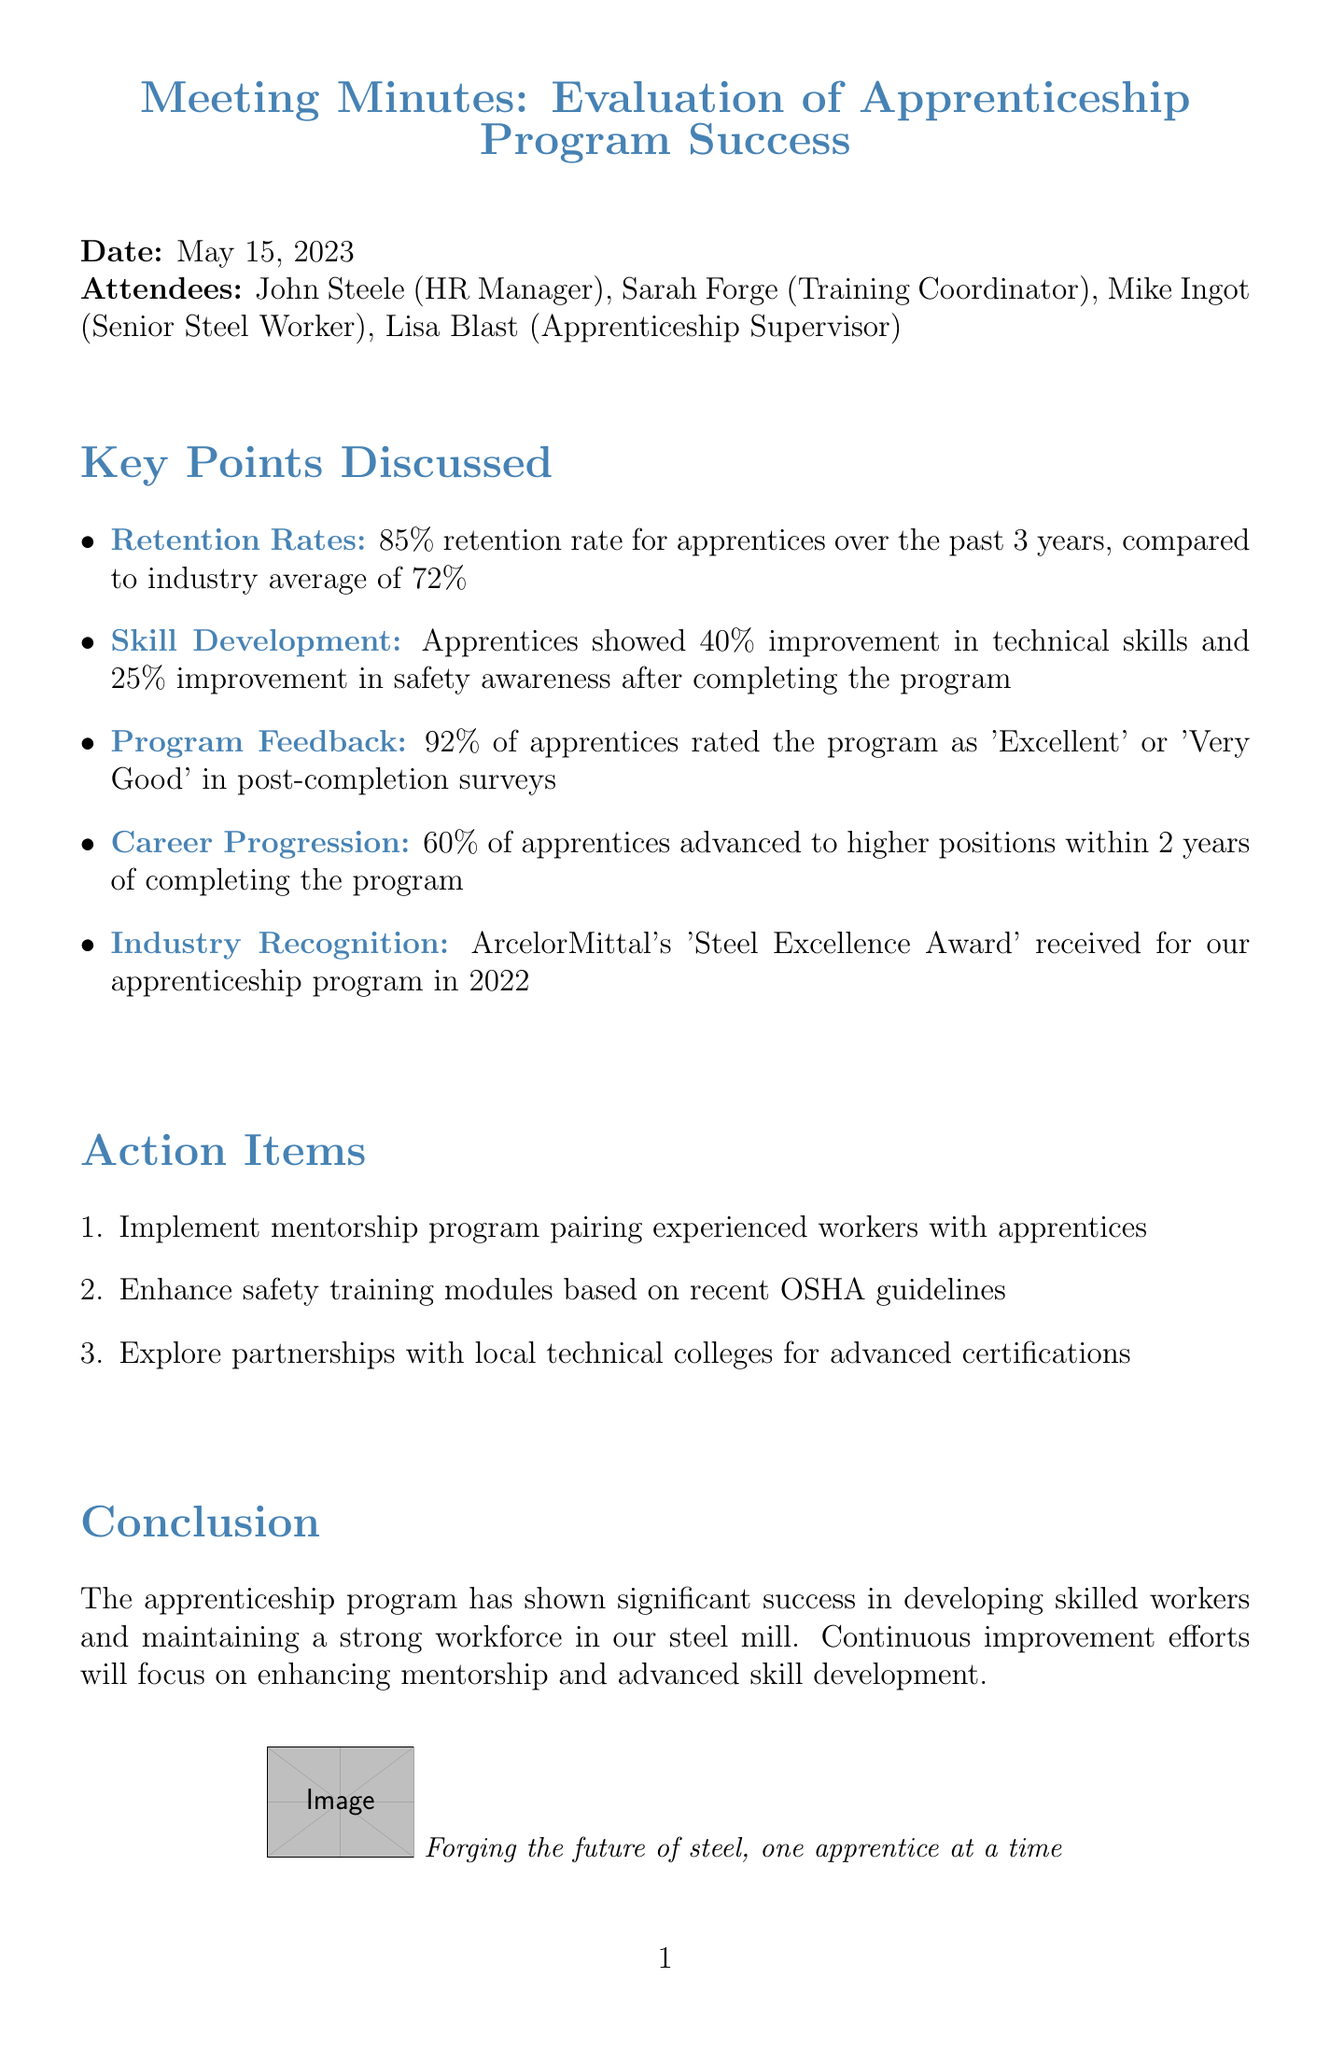What is the date of the meeting? The date of the meeting is stated at the top of the document.
Answer: May 15, 2023 What percentage of apprentices rated the program as 'Excellent' or 'Very Good'? This percentage is mentioned in the program feedback section of the document.
Answer: 92% How much improvement did apprentices show in technical skills? This information is detailed under the skill development section in the document.
Answer: 40% What is the retention rate of apprentices over the past 3 years? The retention rate is highlighted in the retention rates section.
Answer: 85% What percentage of apprentices advanced to higher positions within 2 years? This statistic is provided in the career progression section of the document.
Answer: 60% What action item involves experienced workers? This action item is listed under the action items section.
Answer: Implement mentorship program pairing experienced workers with apprentices Which award was received for the apprenticeship program in 2022? The award is mentioned in the industry recognition section.
Answer: Steel Excellence Award 